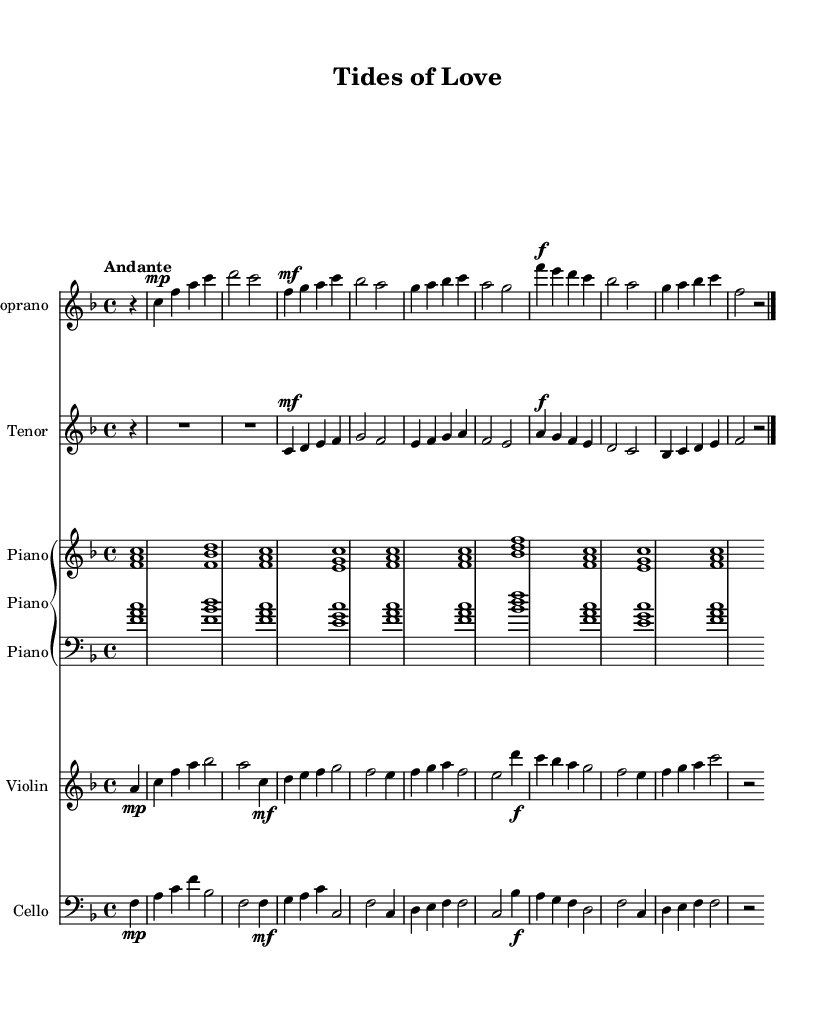What is the key signature of this music? The key signature is F major, which has one flat (B flat). This can be confirmed by looking at the beginning of the staff where the key signature is indicated.
Answer: F major What is the time signature of this piece? The time signature is 4/4, which indicates four beats per measure. This can be confirmed by observing the notation at the beginning of the first staff in the music sheet.
Answer: 4/4 What is the tempo marking for this opera? The tempo marking is "Andante," which indicates a moderately slow tempo. This is typically noted at the beginning of the piece along with other essential markings.
Answer: Andante How many measures are there in the soprano part? The soprano part contains eight measures. This can be determined by counting the groups of notes and rests between the bar lines in the soprano staff.
Answer: Eight What dynamic marking is used for the first note of the tenor part? The first note of the tenor part has a dynamic marking of mezzo-forte. This can be identified by viewing the symbol placed next to the first note in the tenor staff.
Answer: Mezzo-forte Which instruments are featured in this composition? The instruments featured in this composition are Soprano, Tenor, Piano, Violin, and Cello. Each instrument is labeled at the beginning of their respective staff in the score.
Answer: Soprano, Tenor, Piano, Violin, Cello What is the relation of the characters in the opera based on the title? The title suggests a love story between a fisherman and a marine biologist, reflecting their connection to the sea and romance. The title gives a clear thematic indication of the narrative throughout the opera.
Answer: Fisherman and Marine Biologist 